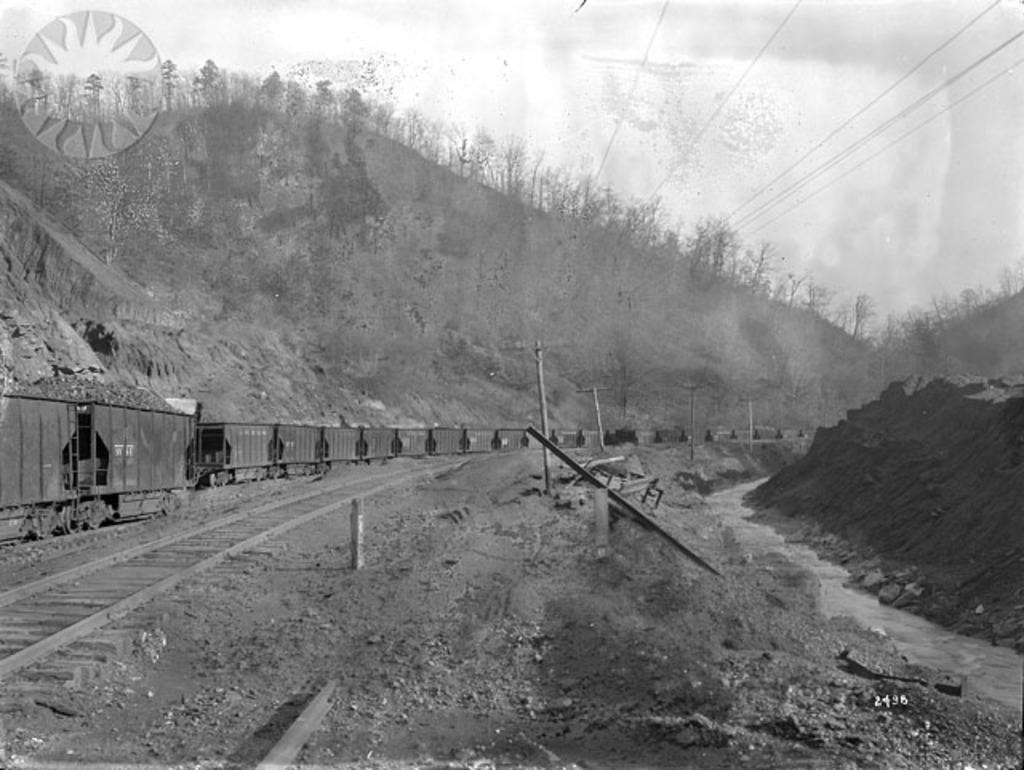Could you give a brief overview of what you see in this image? In this image I can see the hill view ,at the top I can see the sky and power line cable , on the left side I can see the railway track. 